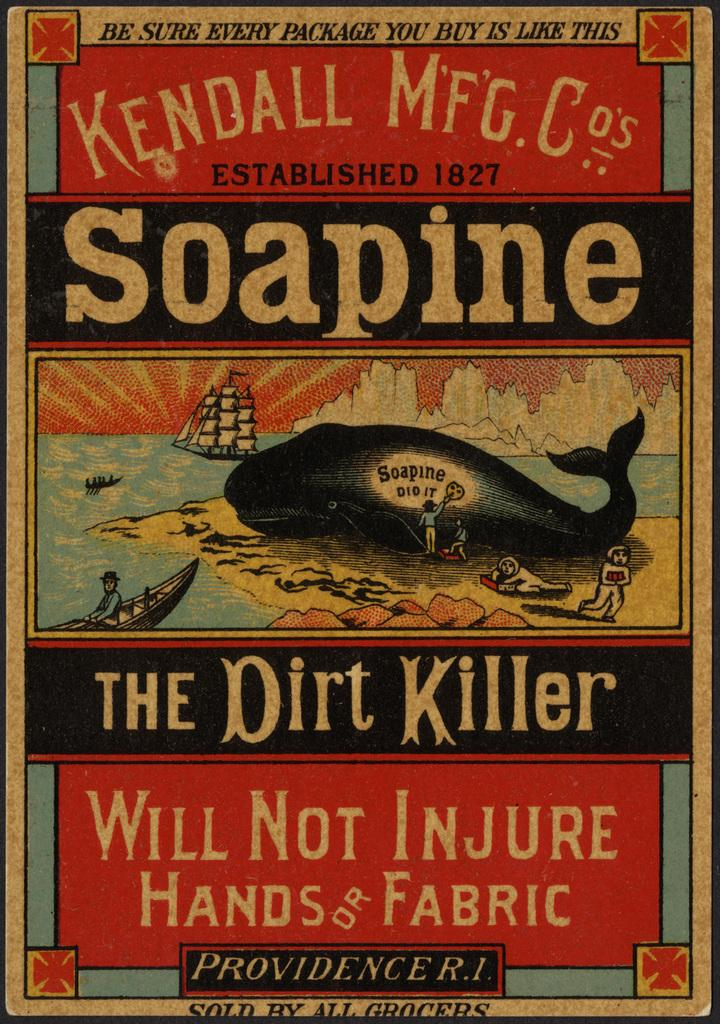<image>
Present a compact description of the photo's key features. front cover of a book named the dirt killer 